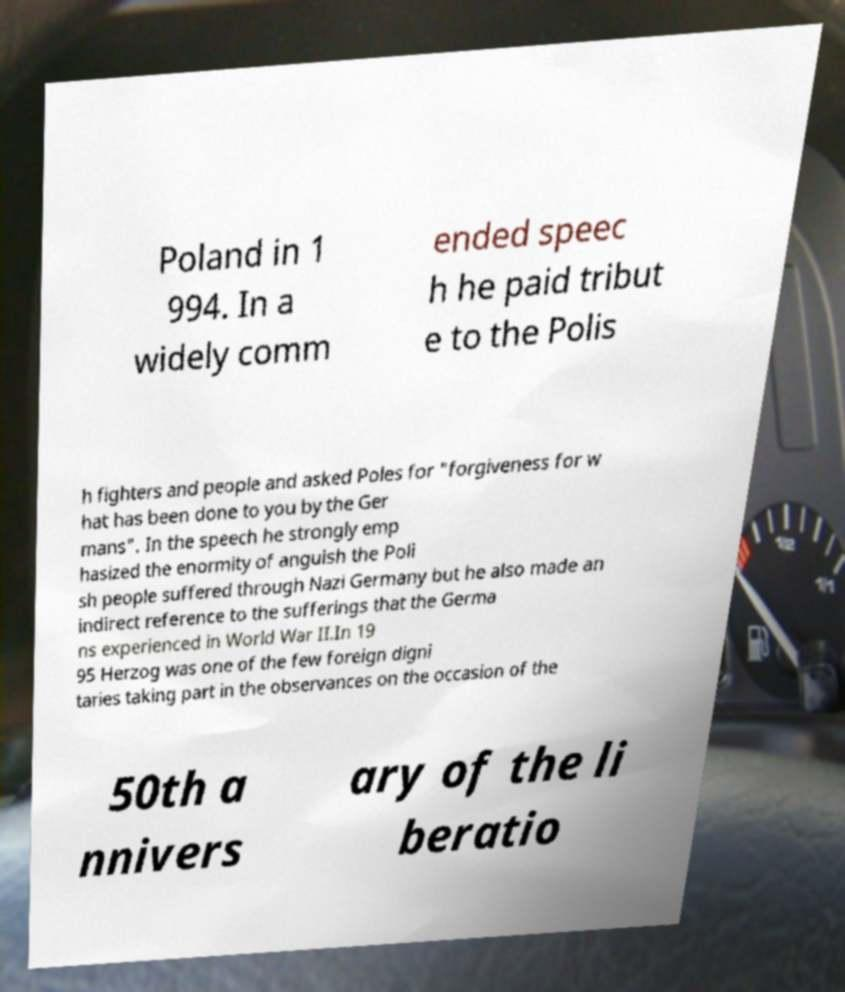There's text embedded in this image that I need extracted. Can you transcribe it verbatim? Poland in 1 994. In a widely comm ended speec h he paid tribut e to the Polis h fighters and people and asked Poles for "forgiveness for w hat has been done to you by the Ger mans". In the speech he strongly emp hasized the enormity of anguish the Poli sh people suffered through Nazi Germany but he also made an indirect reference to the sufferings that the Germa ns experienced in World War II.In 19 95 Herzog was one of the few foreign digni taries taking part in the observances on the occasion of the 50th a nnivers ary of the li beratio 